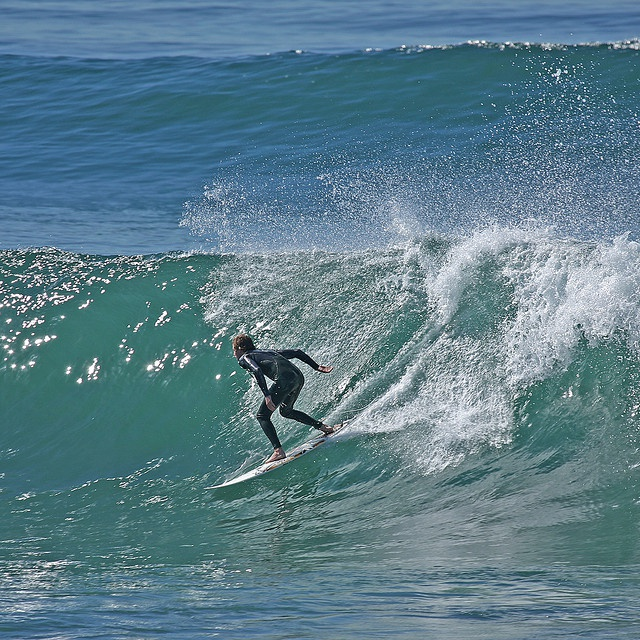Describe the objects in this image and their specific colors. I can see people in gray, black, darkgray, and purple tones and surfboard in gray, white, and darkgray tones in this image. 